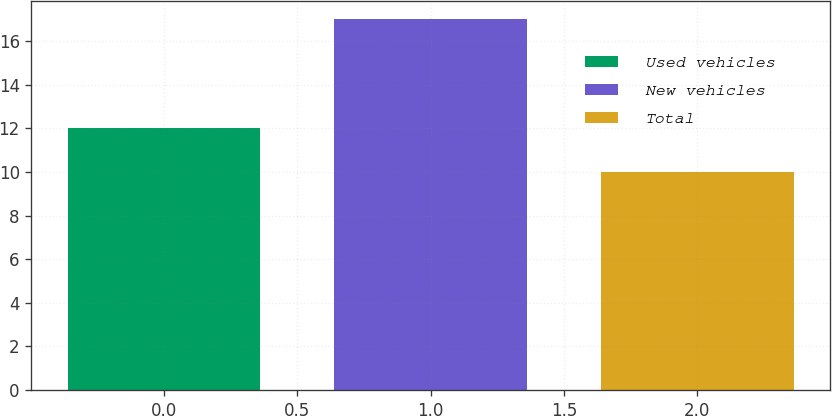Convert chart. <chart><loc_0><loc_0><loc_500><loc_500><bar_chart><fcel>Used vehicles<fcel>New vehicles<fcel>Total<nl><fcel>12<fcel>17<fcel>10<nl></chart> 